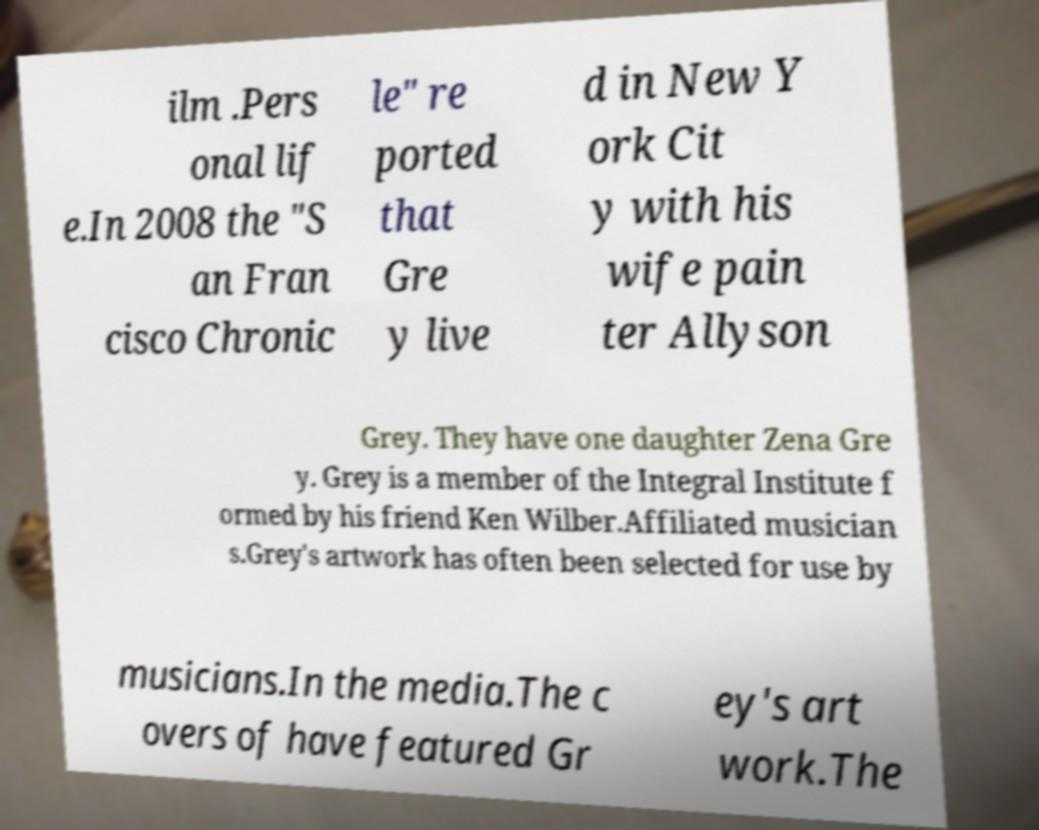Please identify and transcribe the text found in this image. ilm .Pers onal lif e.In 2008 the "S an Fran cisco Chronic le" re ported that Gre y live d in New Y ork Cit y with his wife pain ter Allyson Grey. They have one daughter Zena Gre y. Grey is a member of the Integral Institute f ormed by his friend Ken Wilber.Affiliated musician s.Grey's artwork has often been selected for use by musicians.In the media.The c overs of have featured Gr ey's art work.The 